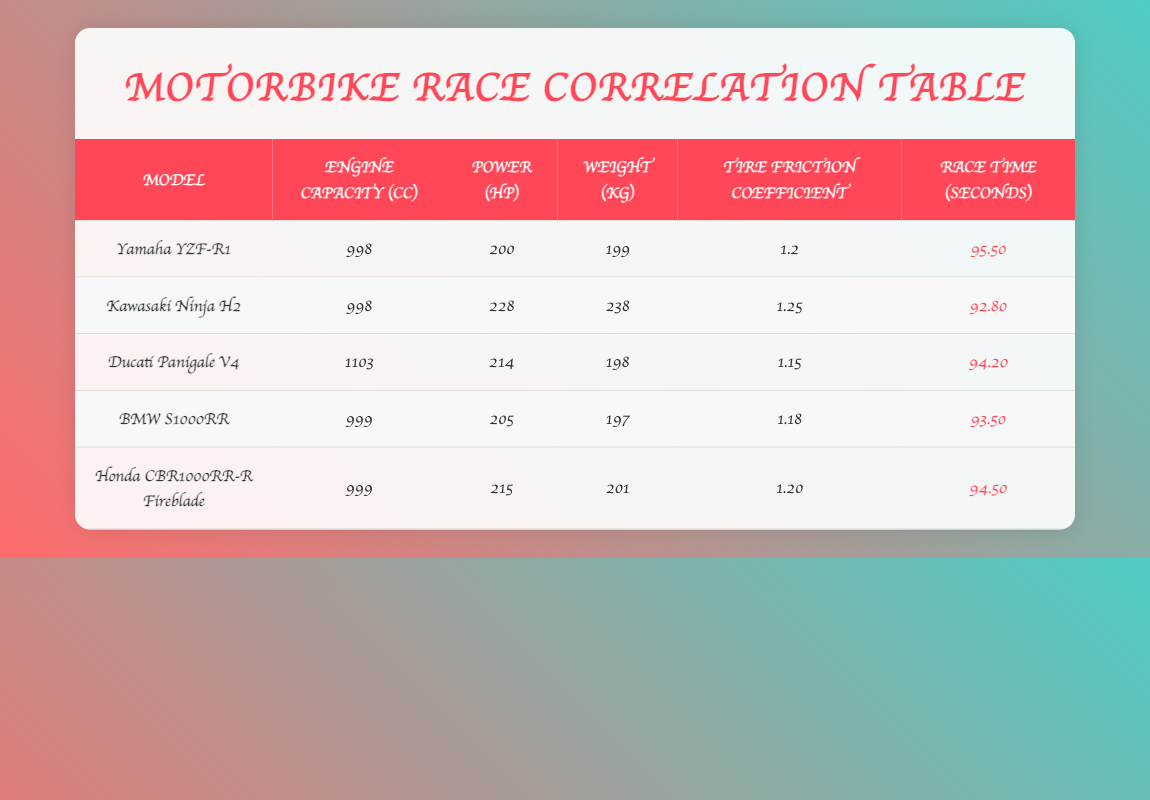What is the race time of the Kawasaki Ninja H2? The Kawasaki Ninja H2's race time is listed in the "Race Time (seconds)" column of the table. According to the data, it is 92.80 seconds.
Answer: 92.80 seconds Which motorbike has the least weight? To find the least weight, I will compare the "Weight (kg)" for all models in the table. The lowest value is found for the BMW S1000RR, which weighs 197 kg.
Answer: BMW S1000RR What is the average power in horsepower of all motorbikes listed? I will sum the power of all models: 200 + 228 + 214 + 205 + 215 = 1082 hp. There are 5 motorbikes, so the average power is 1082 / 5 = 216.4 hp.
Answer: 216.4 hp Is the tire friction coefficient of the Ducati Panigale V4 greater than that of the Yamaha YZF-R1? The tire friction coefficient for the Ducati Panigale V4 is 1.15, while for the Yamaha YZF-R1, it is 1.2. Since 1.15 is less than 1.2, the statement is false.
Answer: No Which motorbike has the highest power-to-weight ratio? First, I will calculate the power-to-weight ratio for each motorbike by dividing the power (hp) by the weight (kg). The calculations are: Yamaha YZF-R1: 200/199 = 1.005, Kawasaki Ninja H2: 228/238 = 0.957, Ducati Panigale V4: 214/198 = 1.080, BMW S1000RR: 205/197 = 1.041, Honda CBR1000RR-R Fireblade: 215/201 = 1.070. The highest ratio is for the Ducati Panigale V4 at 1.080.
Answer: Ducati Panigale V4 What is the difference in race times between the fastest and the slowest motorbikes? The fastest race time is for the Kawasaki Ninja H2 at 92.80 seconds, while the slowest is for the Yamaha YZF-R1 at 95.50 seconds. The difference is 95.50 - 92.80 = 2.70 seconds.
Answer: 2.70 seconds 